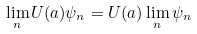<formula> <loc_0><loc_0><loc_500><loc_500>\lim _ { n } U ( a ) \psi _ { n } = U ( a ) \lim _ { n } \psi _ { n }</formula> 